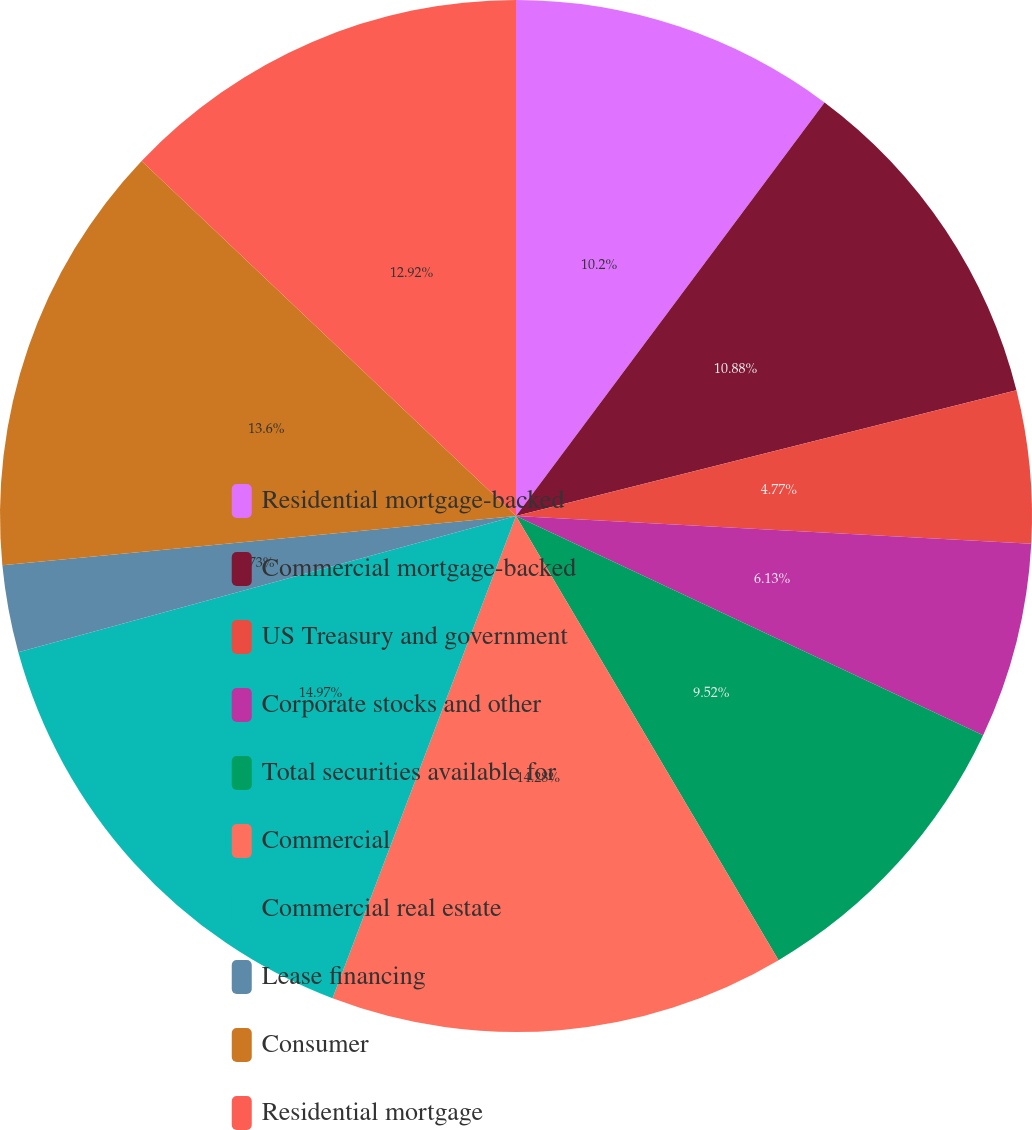Convert chart to OTSL. <chart><loc_0><loc_0><loc_500><loc_500><pie_chart><fcel>Residential mortgage-backed<fcel>Commercial mortgage-backed<fcel>US Treasury and government<fcel>Corporate stocks and other<fcel>Total securities available for<fcel>Commercial<fcel>Commercial real estate<fcel>Lease financing<fcel>Consumer<fcel>Residential mortgage<nl><fcel>10.2%<fcel>10.88%<fcel>4.77%<fcel>6.13%<fcel>9.52%<fcel>14.28%<fcel>14.96%<fcel>2.73%<fcel>13.6%<fcel>12.92%<nl></chart> 